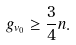Convert formula to latex. <formula><loc_0><loc_0><loc_500><loc_500>g _ { { v } _ { 0 } } & \geq \frac { 3 } { 4 } n .</formula> 